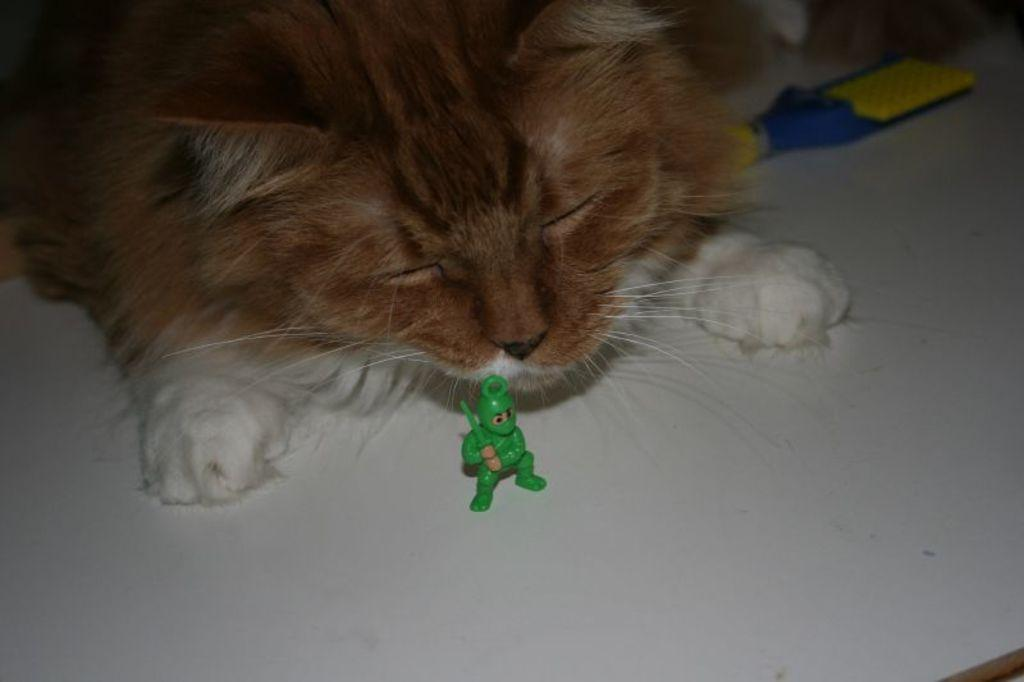What type of animal is present in the image? There is a cat in the image. What can be seen on the white surface in the image? There are objects on a white surface in the image. What color is the bait used by the cat in the image? There is no bait present in the image, and the cat's color is not mentioned in the provided facts. 